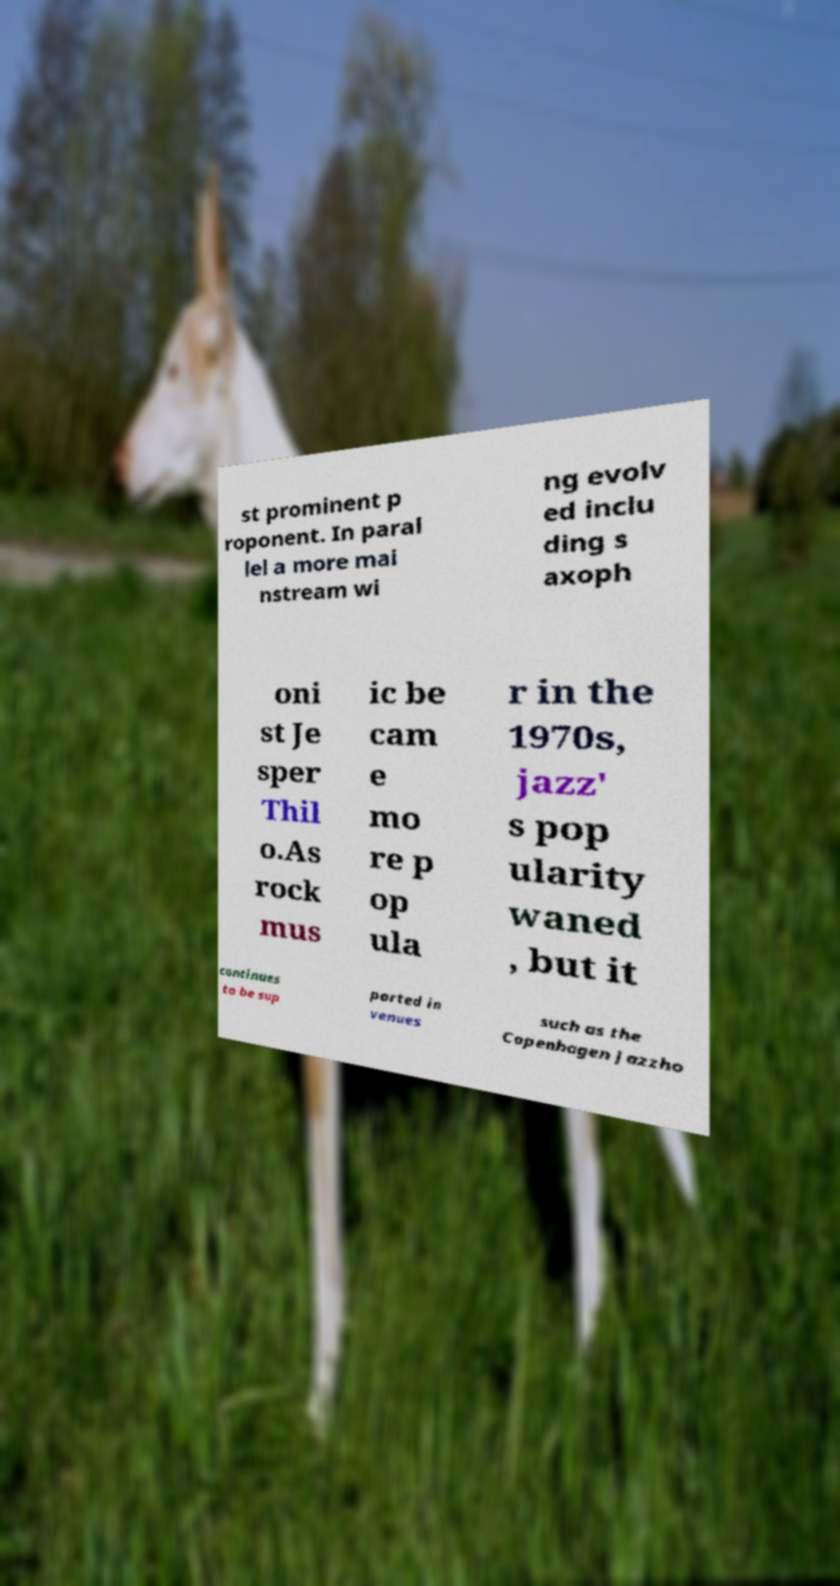Could you assist in decoding the text presented in this image and type it out clearly? st prominent p roponent. In paral lel a more mai nstream wi ng evolv ed inclu ding s axoph oni st Je sper Thil o.As rock mus ic be cam e mo re p op ula r in the 1970s, jazz' s pop ularity waned , but it continues to be sup ported in venues such as the Copenhagen Jazzho 